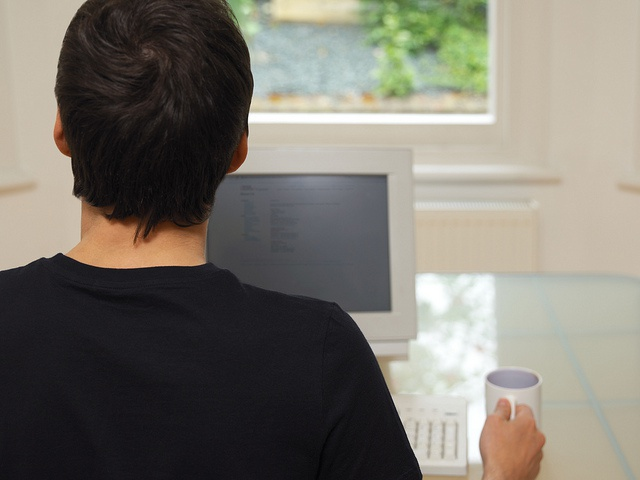Describe the objects in this image and their specific colors. I can see people in darkgray, black, tan, salmon, and maroon tones, tv in darkgray, gray, and lightgray tones, keyboard in darkgray and lightgray tones, and cup in darkgray and lightgray tones in this image. 